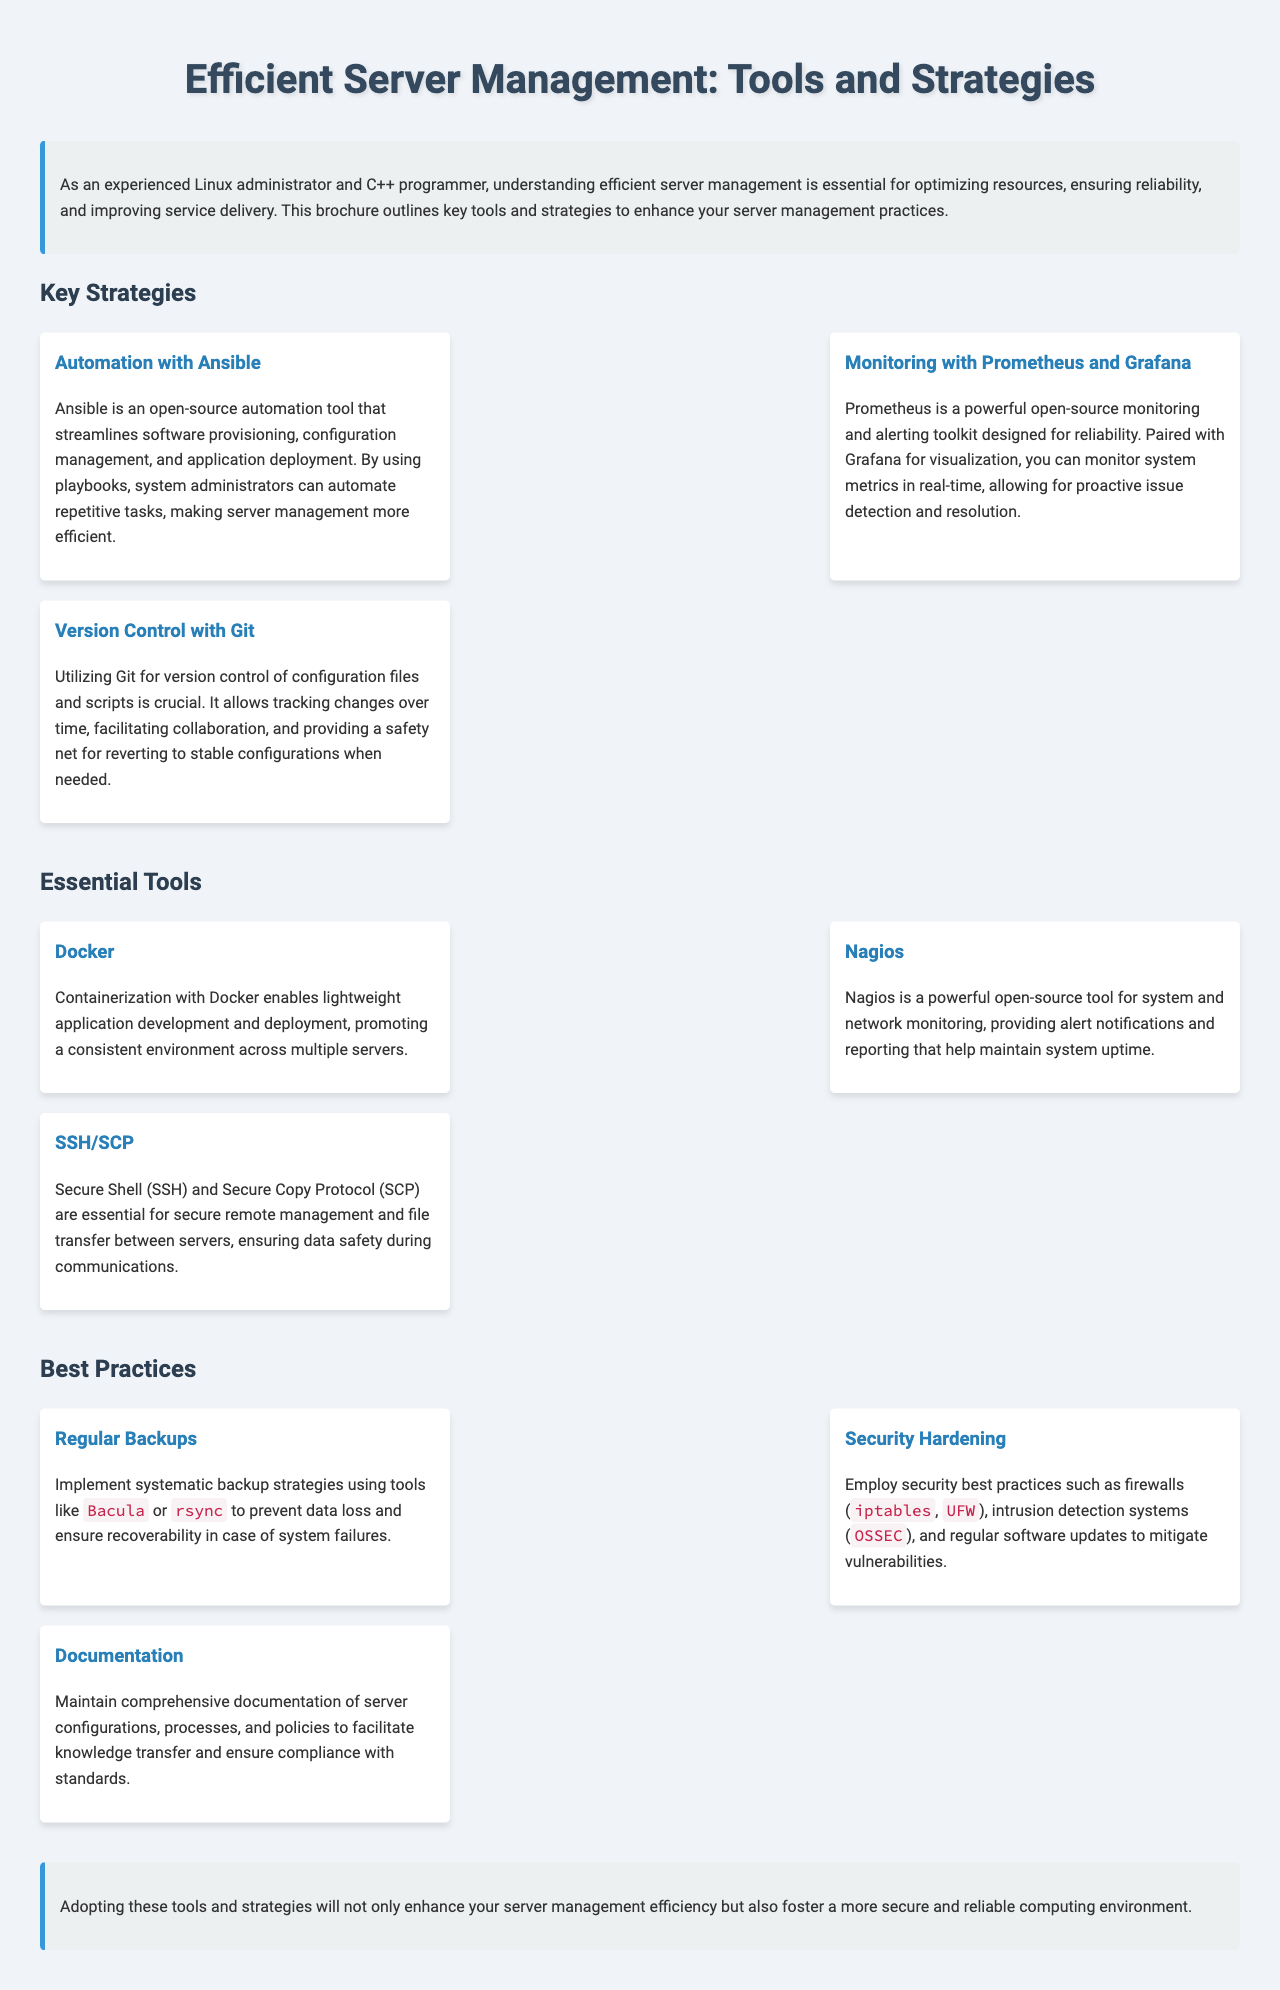What is the title of the brochure? The title is mentioned at the top of the document, highlighting the main topic of discussion.
Answer: Efficient Server Management: Tools and Strategies What tool is recommended for automation? The document lists specific tools and their uses, including one for automation purposes.
Answer: Ansible Which monitoring toolkit is paired with Grafana? Contextual information in the document refers to a specific toolkit associated with Grafana for monitoring.
Answer: Prometheus What is one recommended practice for server management? The document outlines several best practices, detailing effective methods for managing servers.
Answer: Regular Backups What is the main focus of security hardening? The document summarizes security best practices, referencing specific areas of focus for enhancing security.
Answer: Mitigate vulnerabilities How many strategies are listed in the brochure? The document lists different strategies for efficient server management, providing a total count.
Answer: Three Which tool is mentioned for containerization? The document specifies a tool that facilitates containerization, allowing for efficient application development.
Answer: Docker What is a benefit of using Git mentioned in the brochure? The reasoning connects the use of Git to managing configuration files and collaboration efficiently.
Answer: Tracking changes What type of management does SSH/SCP facilitate? The document describes the purpose of these protocols, determining their role in server management.
Answer: Secure remote management 